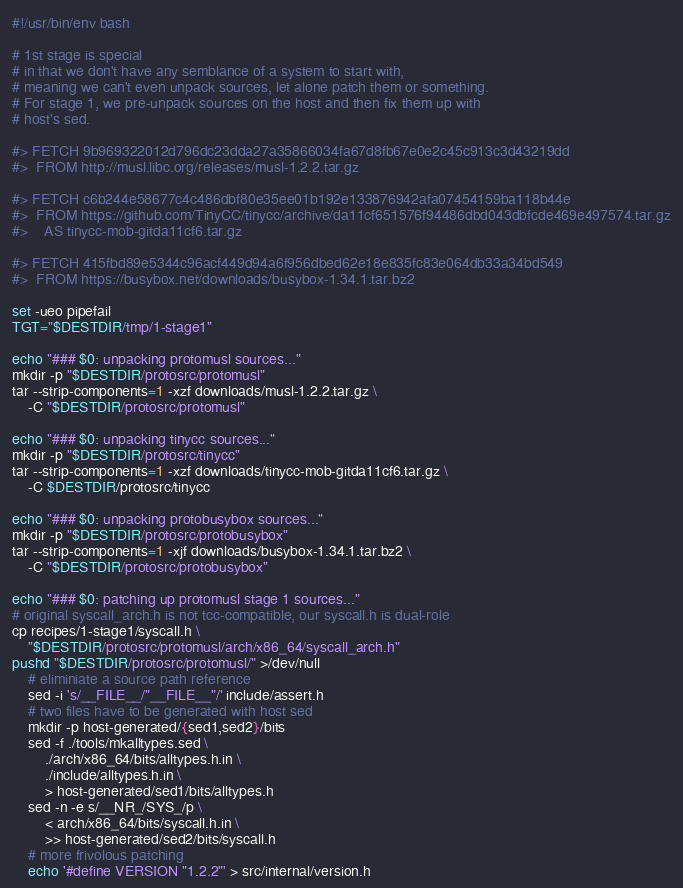<code> <loc_0><loc_0><loc_500><loc_500><_Bash_>#!/usr/bin/env bash

# 1st stage is special
# in that we don't have any semblance of a system to start with,
# meaning we can't even unpack sources, let alone patch them or something.
# For stage 1, we pre-unpack sources on the host and then fix them up with
# host's sed.

#> FETCH 9b969322012d796dc23dda27a35866034fa67d8fb67e0e2c45c913c3d43219dd
#>  FROM http://musl.libc.org/releases/musl-1.2.2.tar.gz

#> FETCH c6b244e58677c4c486dbf80e35ee01b192e133876942afa07454159ba118b44e
#>  FROM https://github.com/TinyCC/tinycc/archive/da11cf651576f94486dbd043dbfcde469e497574.tar.gz
#>    AS tinycc-mob-gitda11cf6.tar.gz

#> FETCH 415fbd89e5344c96acf449d94a6f956dbed62e18e835fc83e064db33a34bd549
#>  FROM https://busybox.net/downloads/busybox-1.34.1.tar.bz2

set -ueo pipefail
TGT="$DESTDIR/tmp/1-stage1"

echo "### $0: unpacking protomusl sources..."
mkdir -p "$DESTDIR/protosrc/protomusl"
tar --strip-components=1 -xzf downloads/musl-1.2.2.tar.gz \
	-C "$DESTDIR/protosrc/protomusl"

echo "### $0: unpacking tinycc sources..."
mkdir -p "$DESTDIR/protosrc/tinycc"
tar --strip-components=1 -xzf downloads/tinycc-mob-gitda11cf6.tar.gz \
	-C $DESTDIR/protosrc/tinycc

echo "### $0: unpacking protobusybox sources..."
mkdir -p "$DESTDIR/protosrc/protobusybox"
tar --strip-components=1 -xjf downloads/busybox-1.34.1.tar.bz2 \
	-C "$DESTDIR/protosrc/protobusybox"

echo "### $0: patching up protomusl stage 1 sources..."
# original syscall_arch.h is not tcc-compatible, our syscall.h is dual-role
cp recipes/1-stage1/syscall.h \
	"$DESTDIR/protosrc/protomusl/arch/x86_64/syscall_arch.h"
pushd "$DESTDIR/protosrc/protomusl/" >/dev/null
	# eliminiate a source path reference
	sed -i 's/__FILE__/"__FILE__"/' include/assert.h
	# two files have to be generated with host sed
	mkdir -p host-generated/{sed1,sed2}/bits
	sed -f ./tools/mkalltypes.sed \
		./arch/x86_64/bits/alltypes.h.in \
		./include/alltypes.h.in \
		> host-generated/sed1/bits/alltypes.h
	sed -n -e s/__NR_/SYS_/p \
		< arch/x86_64/bits/syscall.h.in \
		>> host-generated/sed2/bits/syscall.h
	# more frivolous patching
	echo '#define VERSION "1.2.2"' > src/internal/version.h</code> 